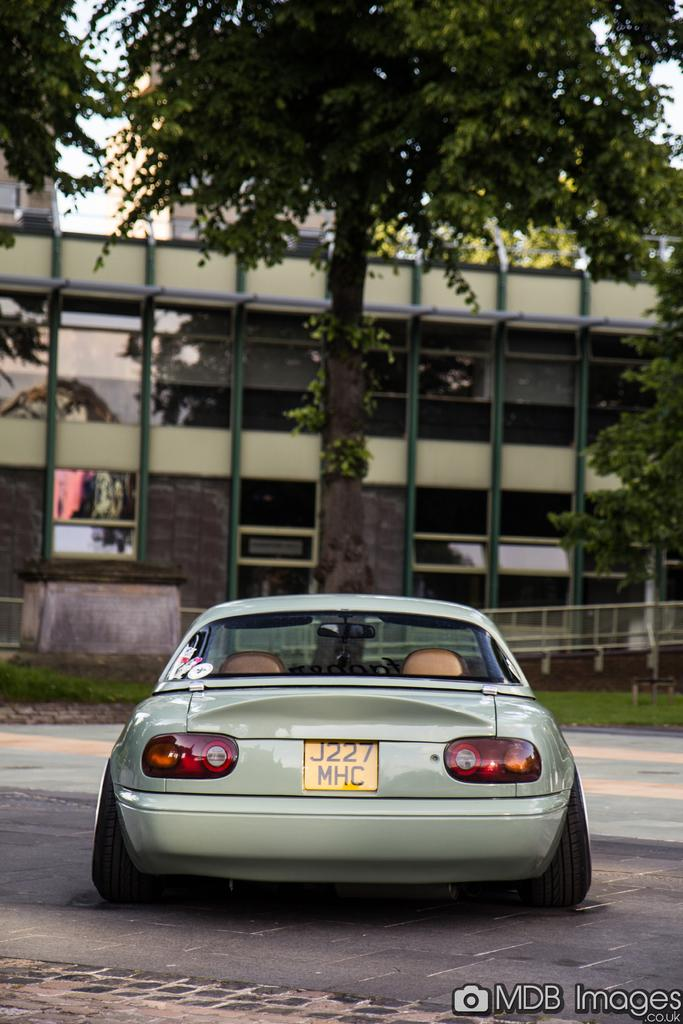What is on the road in the image? There is a vehicle on the road in the image. What can be seen in the background of the image? There are trees, a building, and grass in the background of the image. What type of windows does the building have? The building has glass windows. Is there any additional information about the image itself? Yes, there is a watermark at the bottom of the image. Can you see any steam coming from the vehicle's exhaust in the image? There is no mention of steam or exhaust in the provided facts, so it cannot be determined from the image. 